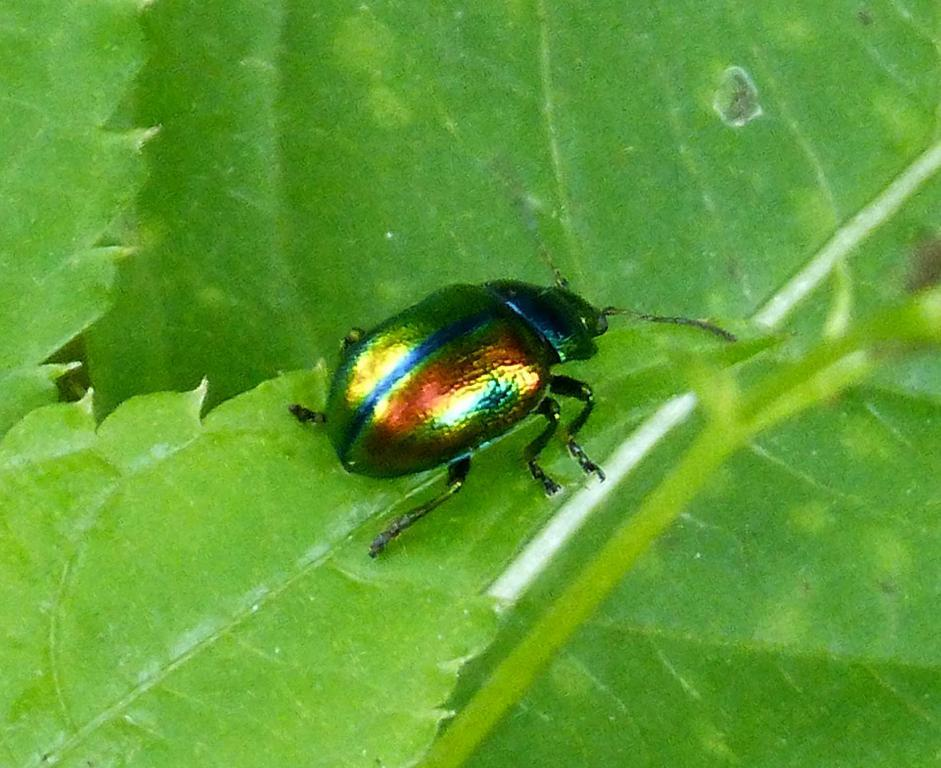What is present on the leaf in the image? There is an insect on a leaf in the image. Can you describe the surrounding environment in the image? There are other leaves visible in the image. What type of harmony is being played by the insect in the image? There is no indication of music or harmony in the image; it features an insect on a leaf. 